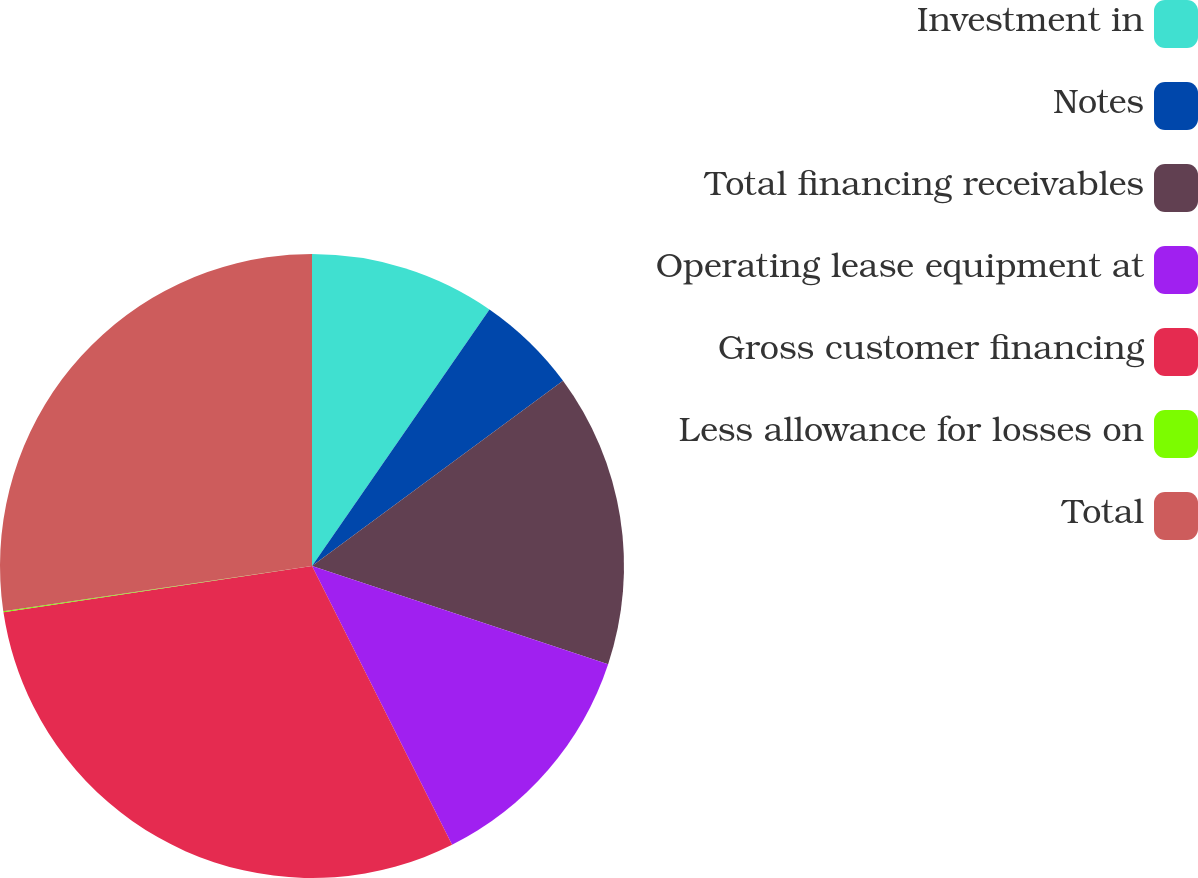<chart> <loc_0><loc_0><loc_500><loc_500><pie_chart><fcel>Investment in<fcel>Notes<fcel>Total financing receivables<fcel>Operating lease equipment at<fcel>Gross customer financing<fcel>Less allowance for losses on<fcel>Total<nl><fcel>9.63%<fcel>5.25%<fcel>15.22%<fcel>12.49%<fcel>30.04%<fcel>0.06%<fcel>27.31%<nl></chart> 